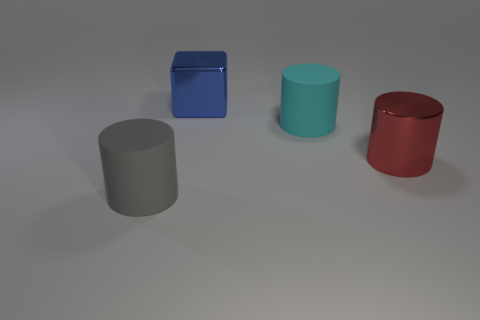How many things are rubber cylinders that are in front of the big red cylinder or large matte cylinders that are left of the cube?
Your response must be concise. 1. Are there more gray cylinders behind the large blue thing than big blue objects on the right side of the gray matte object?
Make the answer very short. No. What is the material of the large red cylinder that is right of the big matte object that is in front of the cyan cylinder to the right of the large shiny cube?
Offer a very short reply. Metal. Is the shape of the matte object behind the large red thing the same as the big gray rubber thing in front of the large cyan object?
Your answer should be compact. Yes. Is there a red shiny cylinder of the same size as the metal cube?
Keep it short and to the point. Yes. What number of blue objects are big metallic blocks or rubber things?
Provide a short and direct response. 1. How many other cylinders have the same color as the metallic cylinder?
Offer a terse response. 0. Is there anything else that has the same shape as the gray rubber thing?
Provide a succinct answer. Yes. What number of balls are either large blue things or small purple rubber objects?
Provide a succinct answer. 0. There is a cylinder left of the blue shiny block; what color is it?
Give a very brief answer. Gray. 